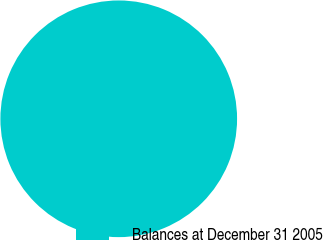Convert chart. <chart><loc_0><loc_0><loc_500><loc_500><pie_chart><fcel>Balances at December 31 2005<nl><fcel>100.0%<nl></chart> 